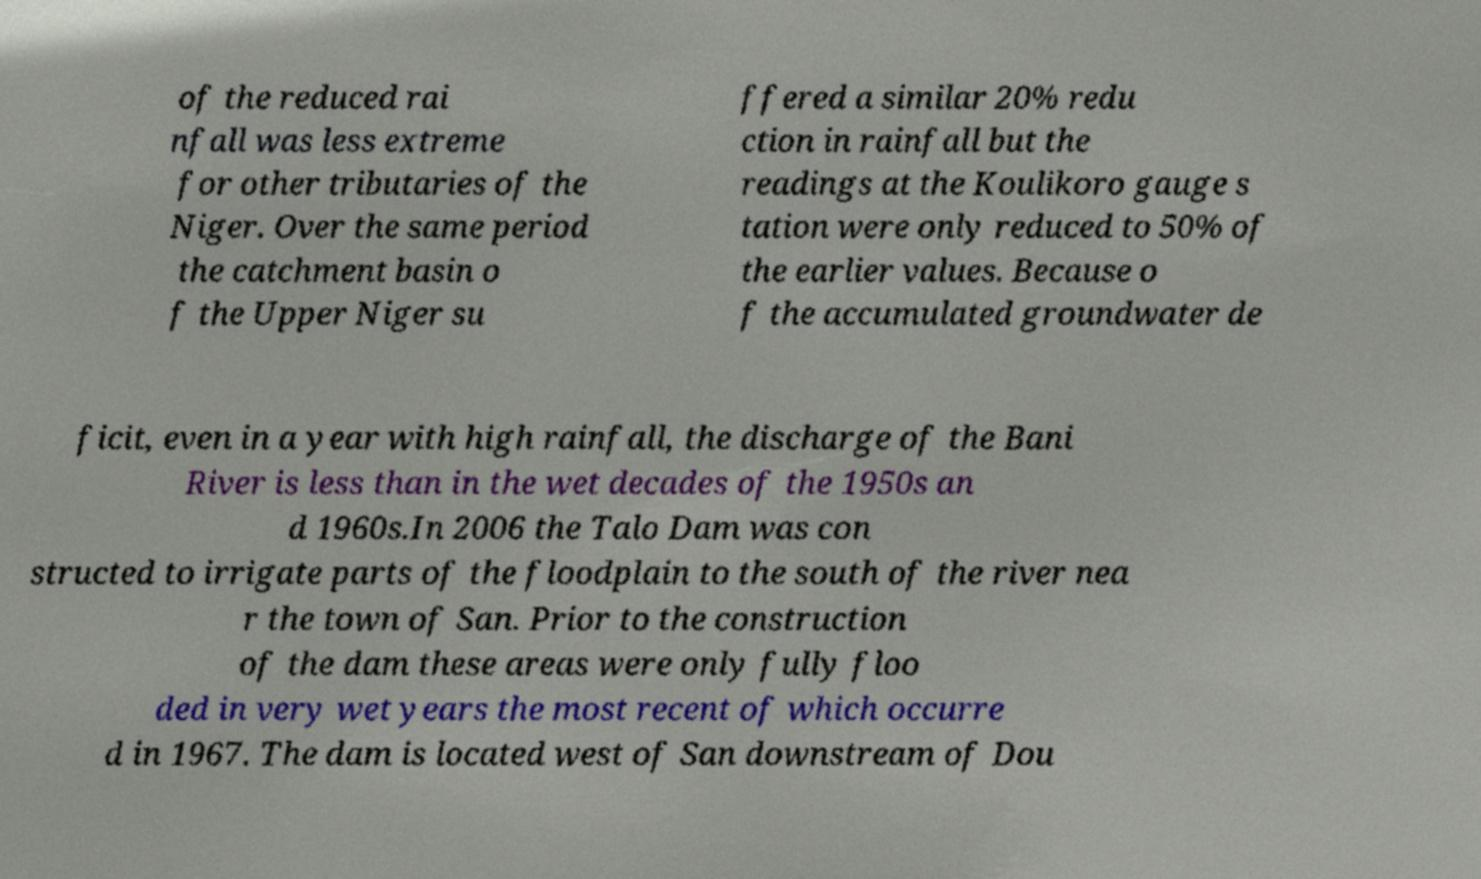There's text embedded in this image that I need extracted. Can you transcribe it verbatim? of the reduced rai nfall was less extreme for other tributaries of the Niger. Over the same period the catchment basin o f the Upper Niger su ffered a similar 20% redu ction in rainfall but the readings at the Koulikoro gauge s tation were only reduced to 50% of the earlier values. Because o f the accumulated groundwater de ficit, even in a year with high rainfall, the discharge of the Bani River is less than in the wet decades of the 1950s an d 1960s.In 2006 the Talo Dam was con structed to irrigate parts of the floodplain to the south of the river nea r the town of San. Prior to the construction of the dam these areas were only fully floo ded in very wet years the most recent of which occurre d in 1967. The dam is located west of San downstream of Dou 